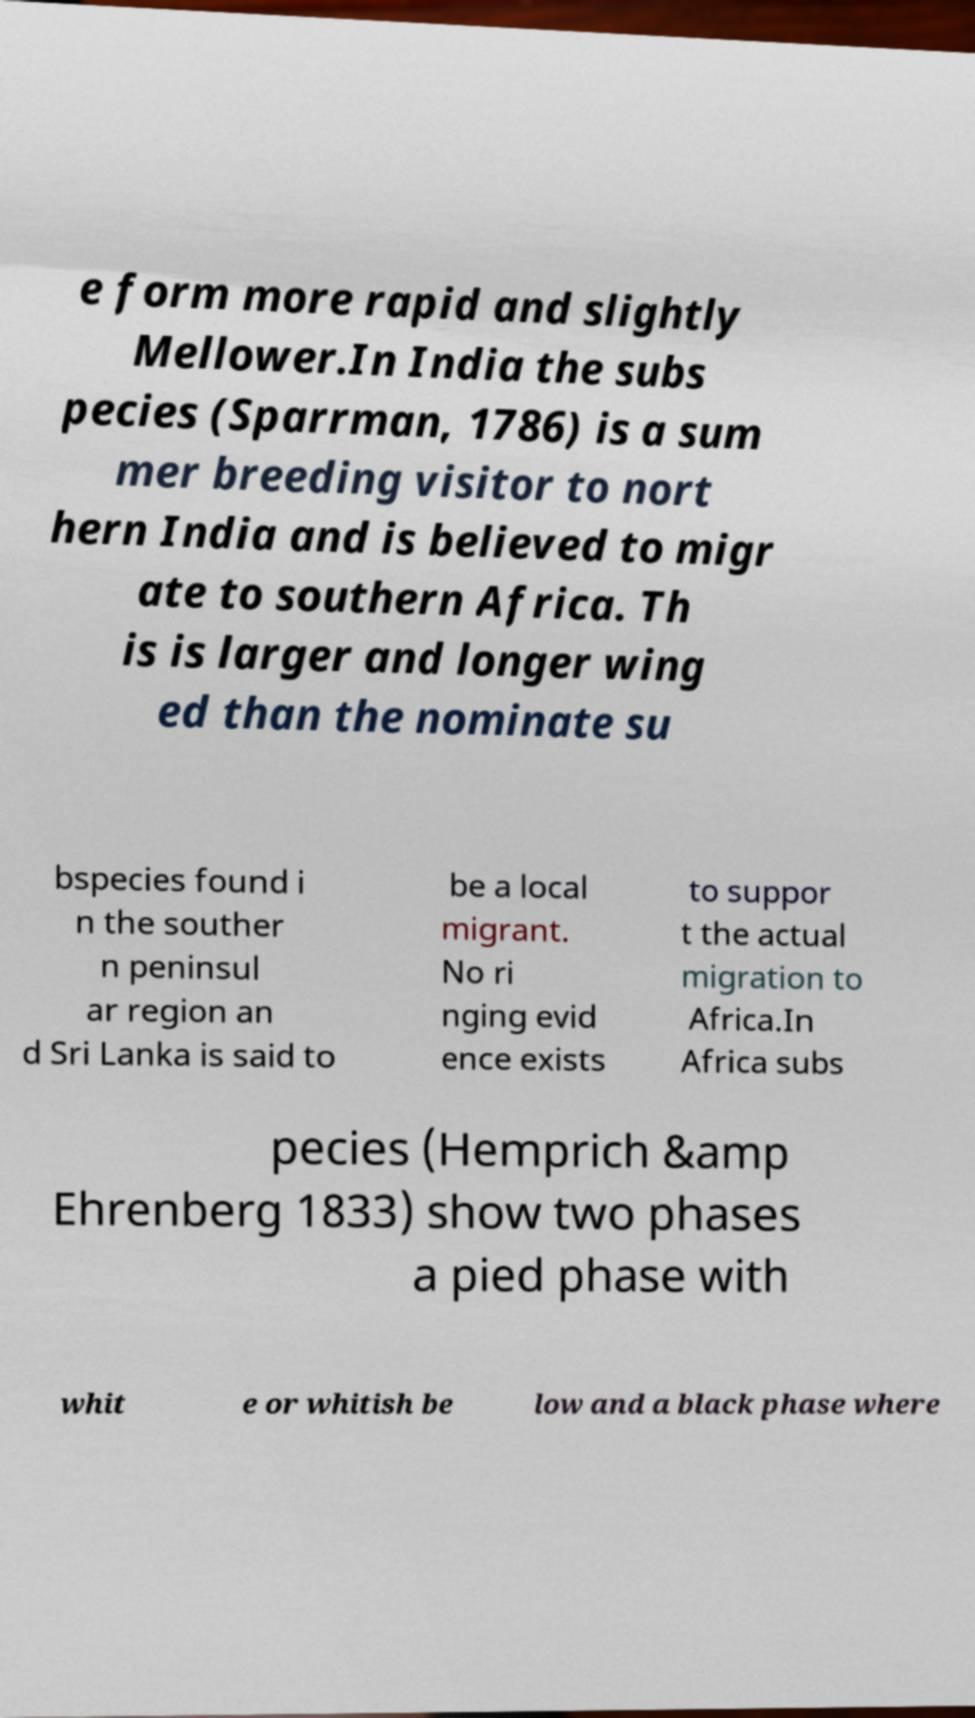Could you assist in decoding the text presented in this image and type it out clearly? e form more rapid and slightly Mellower.In India the subs pecies (Sparrman, 1786) is a sum mer breeding visitor to nort hern India and is believed to migr ate to southern Africa. Th is is larger and longer wing ed than the nominate su bspecies found i n the souther n peninsul ar region an d Sri Lanka is said to be a local migrant. No ri nging evid ence exists to suppor t the actual migration to Africa.In Africa subs pecies (Hemprich &amp Ehrenberg 1833) show two phases a pied phase with whit e or whitish be low and a black phase where 